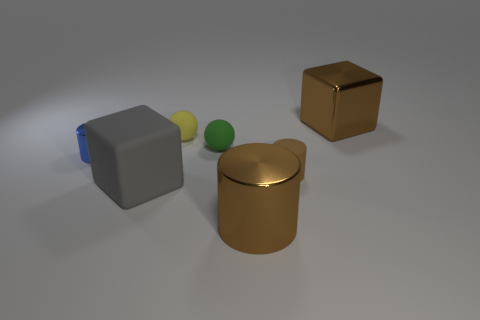How many small things are red balls or yellow spheres?
Provide a succinct answer. 1. Is the shape of the blue thing the same as the tiny brown thing?
Give a very brief answer. Yes. How many big things are on the left side of the large metallic cube and on the right side of the yellow matte sphere?
Your answer should be very brief. 1. Are there any other things that have the same color as the big metal cylinder?
Give a very brief answer. Yes. What is the shape of the large gray thing that is made of the same material as the small yellow sphere?
Give a very brief answer. Cube. Does the brown metallic cylinder have the same size as the yellow ball?
Provide a succinct answer. No. Is the large brown thing left of the small matte cylinder made of the same material as the blue cylinder?
Ensure brevity in your answer.  Yes. There is a brown matte object to the right of the large brown object that is in front of the big metallic block; what number of tiny rubber things are left of it?
Your answer should be compact. 2. Do the brown metallic thing behind the small yellow object and the small yellow matte thing have the same shape?
Offer a very short reply. No. How many things are tiny rubber cylinders or small objects that are behind the brown matte thing?
Your response must be concise. 4. 